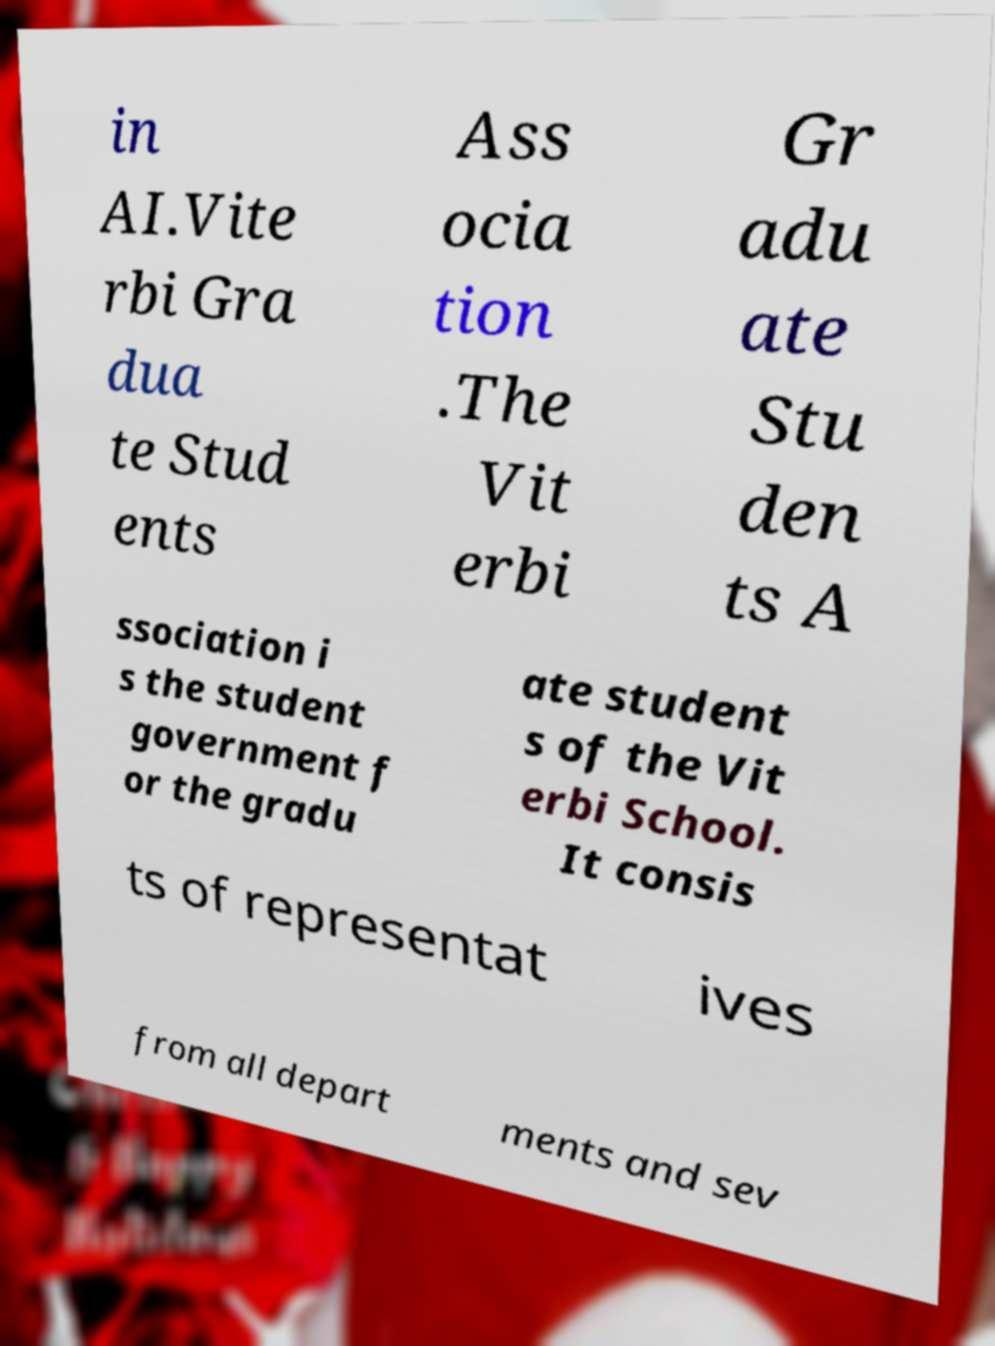Could you extract and type out the text from this image? in AI.Vite rbi Gra dua te Stud ents Ass ocia tion .The Vit erbi Gr adu ate Stu den ts A ssociation i s the student government f or the gradu ate student s of the Vit erbi School. It consis ts of representat ives from all depart ments and sev 